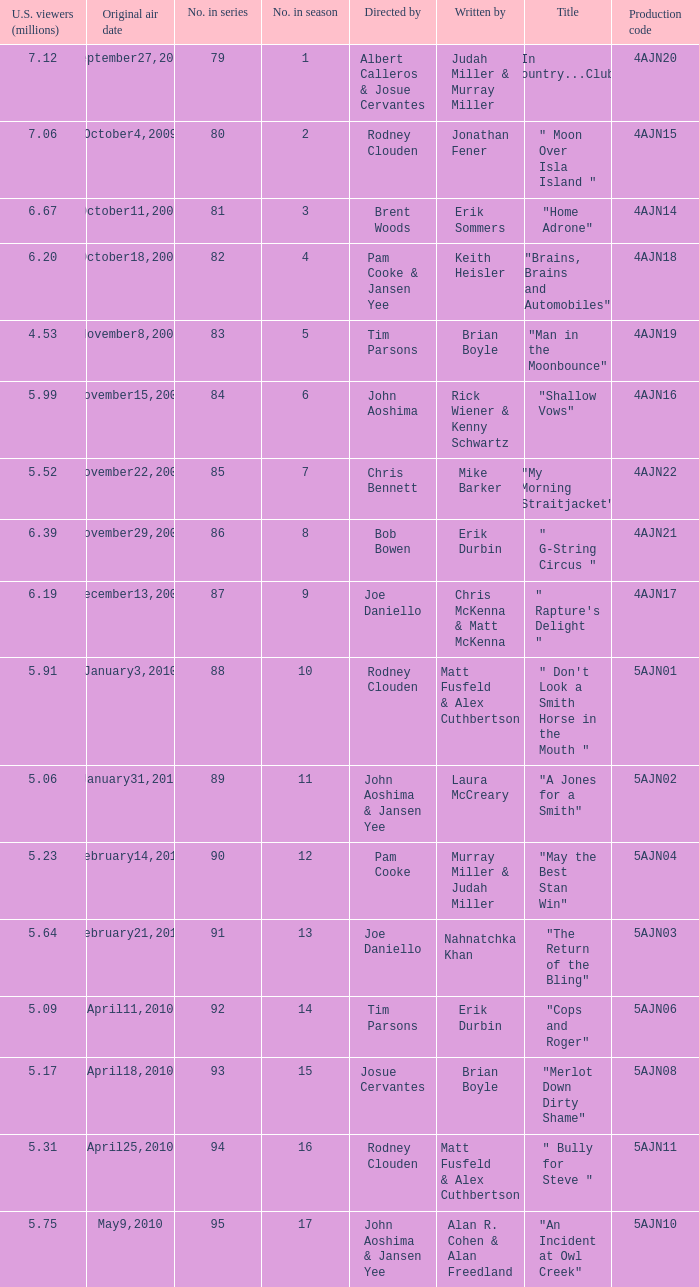Name the original air date for " don't look a smith horse in the mouth " January3,2010. 